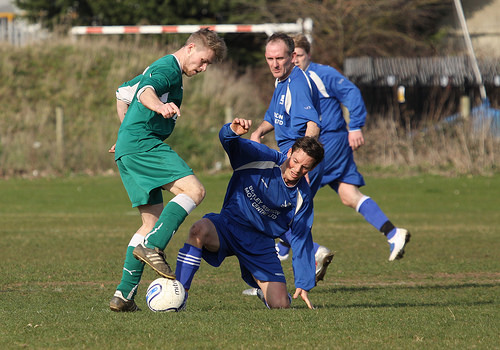<image>
Is there a blue boy behind the green boy? Yes. From this viewpoint, the blue boy is positioned behind the green boy, with the green boy partially or fully occluding the blue boy. 